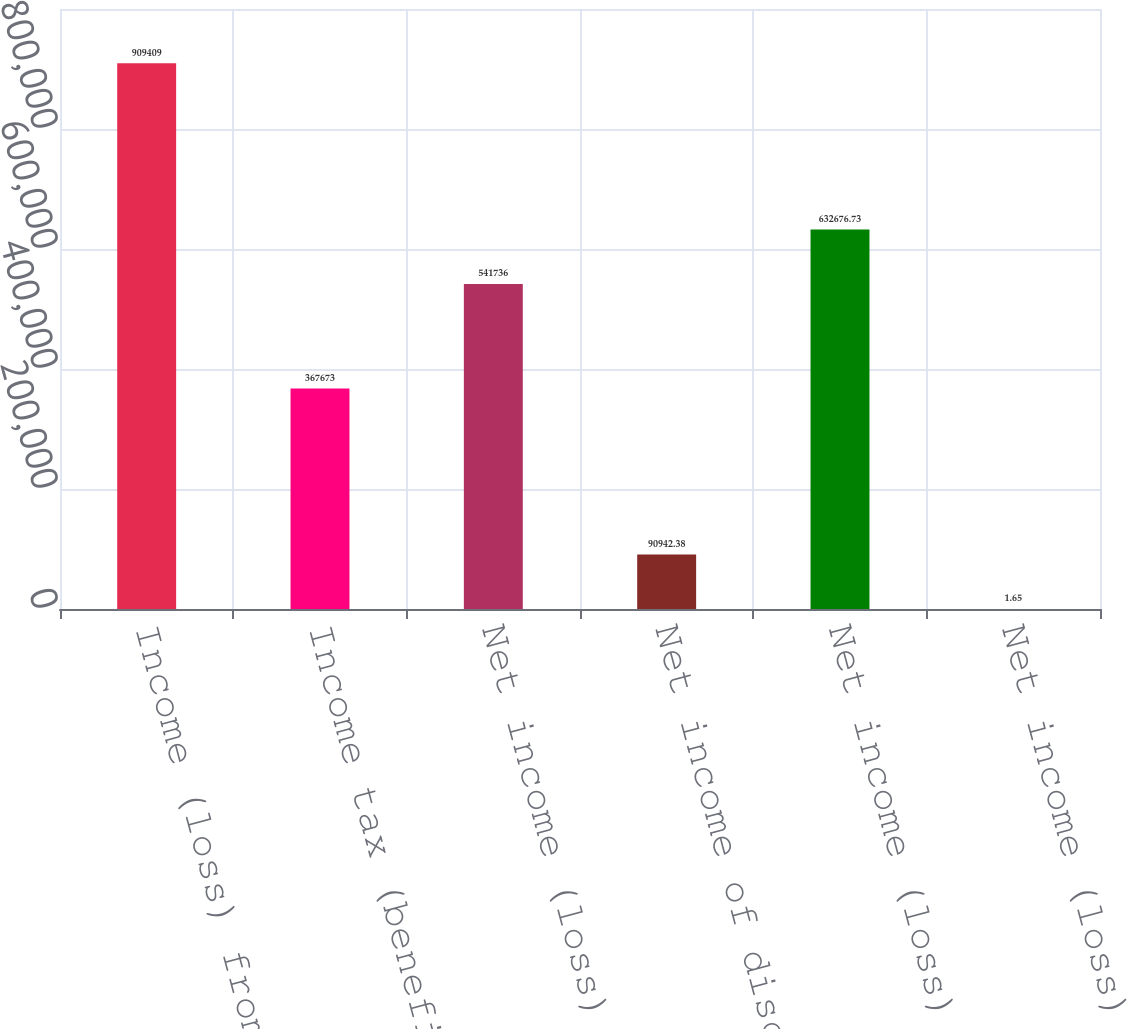<chart> <loc_0><loc_0><loc_500><loc_500><bar_chart><fcel>Income (loss) from continuing<fcel>Income tax (benefit)<fcel>Net income (loss) from<fcel>Net income of discontinued<fcel>Net income (loss)<fcel>Net income (loss) of<nl><fcel>909409<fcel>367673<fcel>541736<fcel>90942.4<fcel>632677<fcel>1.65<nl></chart> 